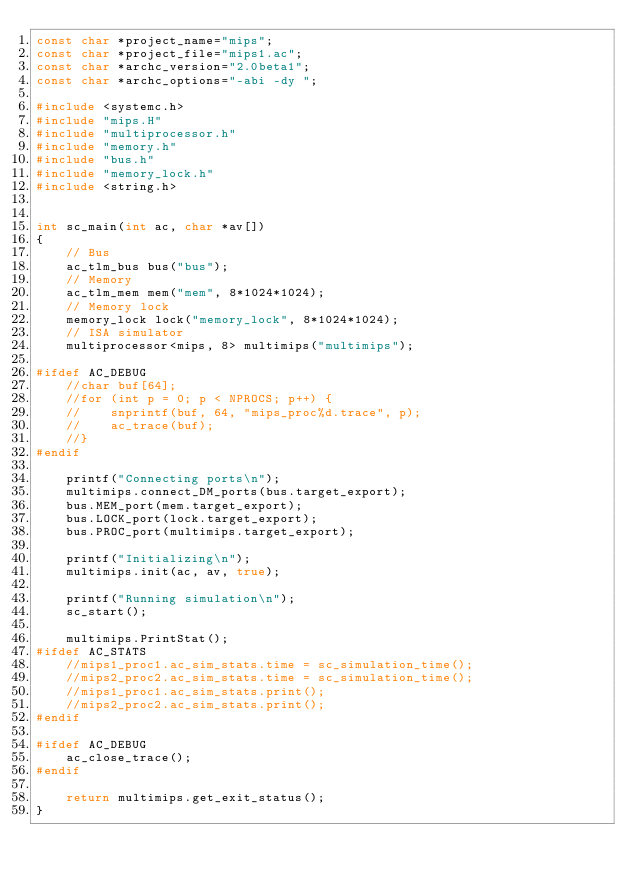<code> <loc_0><loc_0><loc_500><loc_500><_C++_>const char *project_name="mips";
const char *project_file="mips1.ac";
const char *archc_version="2.0beta1";
const char *archc_options="-abi -dy ";

#include <systemc.h>
#include "mips.H"
#include "multiprocessor.h"
#include "memory.h"
#include "bus.h"
#include "memory_lock.h"
#include <string.h>


int sc_main(int ac, char *av[])
{
    // Bus
    ac_tlm_bus bus("bus");
    // Memory
    ac_tlm_mem mem("mem", 8*1024*1024);
    // Memory lock
    memory_lock lock("memory_lock", 8*1024*1024);
    // ISA simulator
    multiprocessor<mips, 8> multimips("multimips");

#ifdef AC_DEBUG
    //char buf[64];
    //for (int p = 0; p < NPROCS; p++) {
    //    snprintf(buf, 64, "mips_proc%d.trace", p);
    //    ac_trace(buf);
    //}
#endif

    printf("Connecting ports\n");
    multimips.connect_DM_ports(bus.target_export);
    bus.MEM_port(mem.target_export);
    bus.LOCK_port(lock.target_export);
    bus.PROC_port(multimips.target_export);

    printf("Initializing\n");
    multimips.init(ac, av, true);

    printf("Running simulation\n");
    sc_start();

    multimips.PrintStat();
#ifdef AC_STATS
    //mips1_proc1.ac_sim_stats.time = sc_simulation_time();
    //mips2_proc2.ac_sim_stats.time = sc_simulation_time();
    //mips1_proc1.ac_sim_stats.print();
    //mips2_proc2.ac_sim_stats.print();
#endif

#ifdef AC_DEBUG
    ac_close_trace();
#endif

    return multimips.get_exit_status();
}
</code> 